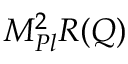<formula> <loc_0><loc_0><loc_500><loc_500>M _ { P l } ^ { 2 } R ( Q )</formula> 